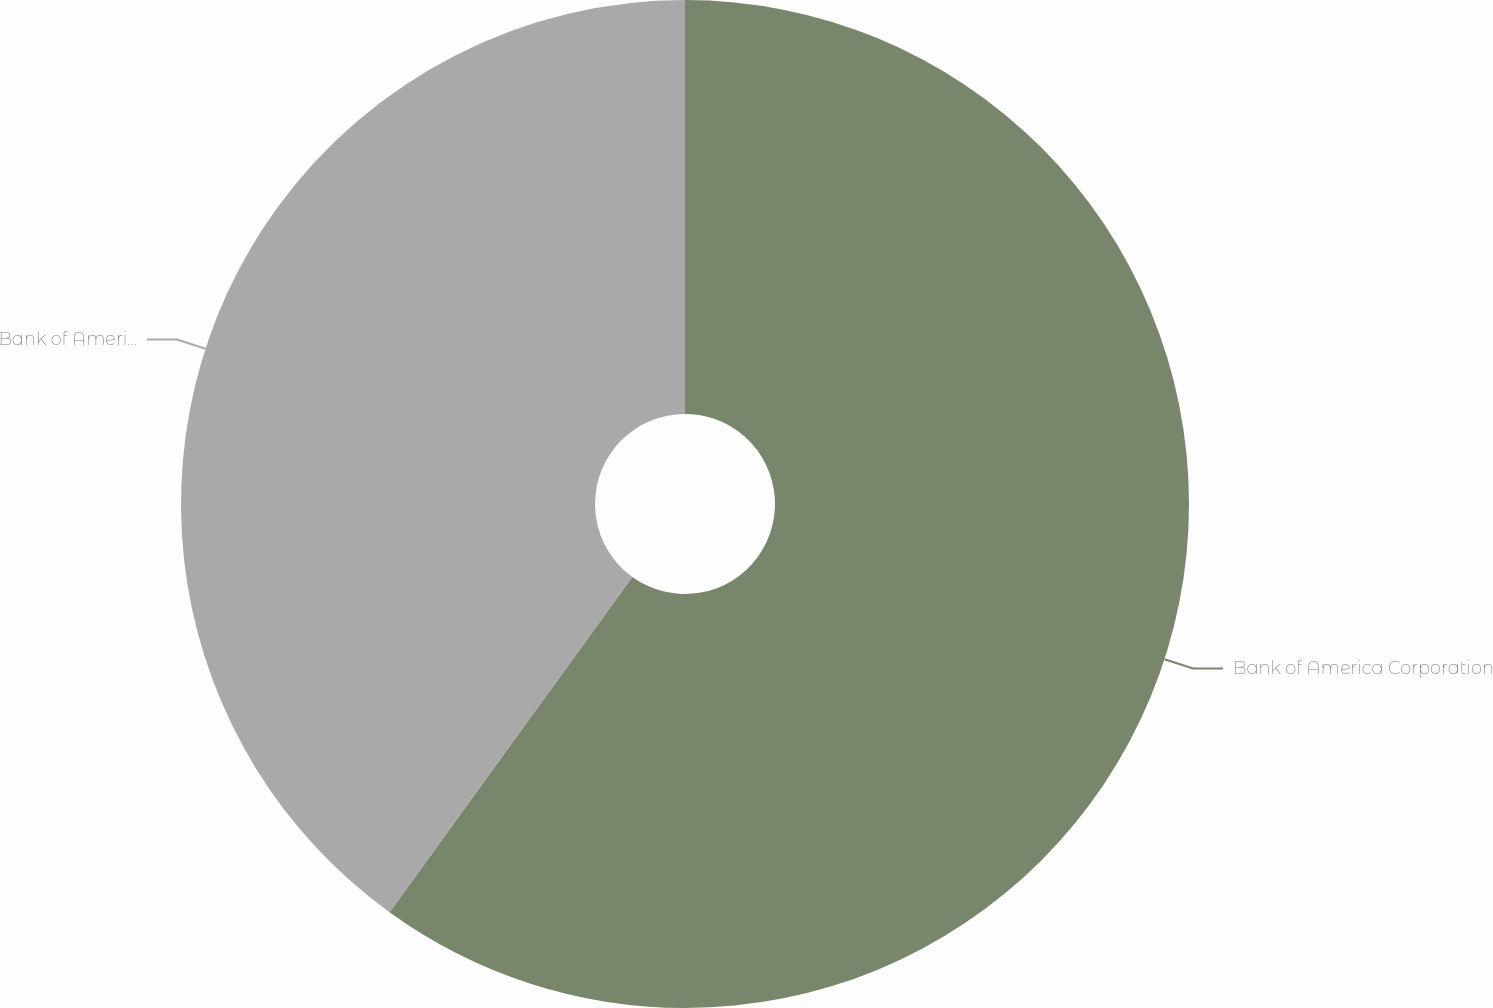<chart> <loc_0><loc_0><loc_500><loc_500><pie_chart><fcel>Bank of America Corporation<fcel>Bank of America NA and<nl><fcel>59.97%<fcel>40.03%<nl></chart> 